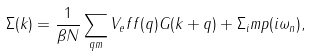Convert formula to latex. <formula><loc_0><loc_0><loc_500><loc_500>\Sigma ( k ) = \frac { 1 } { \beta N } \sum _ { q m } V _ { e } f f ( q ) G ( k + q ) + \Sigma _ { i } m p ( i \omega _ { n } ) ,</formula> 